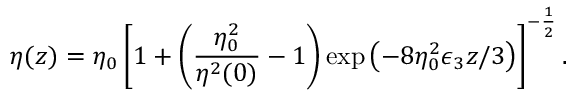Convert formula to latex. <formula><loc_0><loc_0><loc_500><loc_500>\eta ( z ) = \eta _ { 0 } \left [ 1 + \left ( \frac { \eta _ { 0 } ^ { 2 } } { \eta ^ { 2 } ( 0 ) } - 1 \right ) \exp \left ( - 8 \eta _ { 0 } ^ { 2 } \epsilon _ { 3 } z / 3 \right ) \right ] ^ { - \frac { 1 } { 2 } } .</formula> 